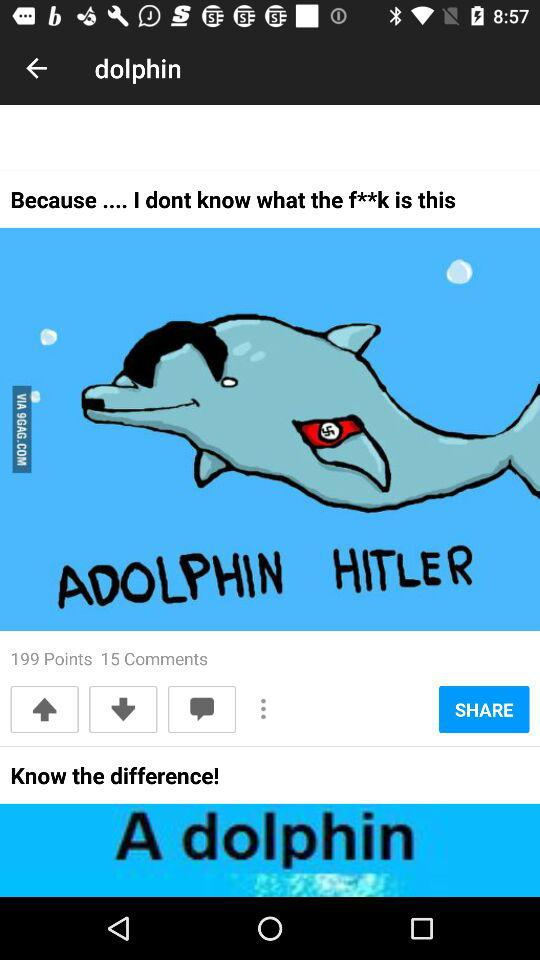How many comments are there? There are 15 comments. 